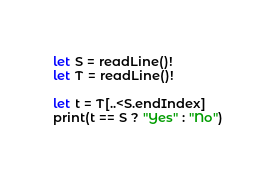<code> <loc_0><loc_0><loc_500><loc_500><_Swift_>let S = readLine()!
let T = readLine()!

let t = T[..<S.endIndex]
print(t == S ? "Yes" : "No")
</code> 